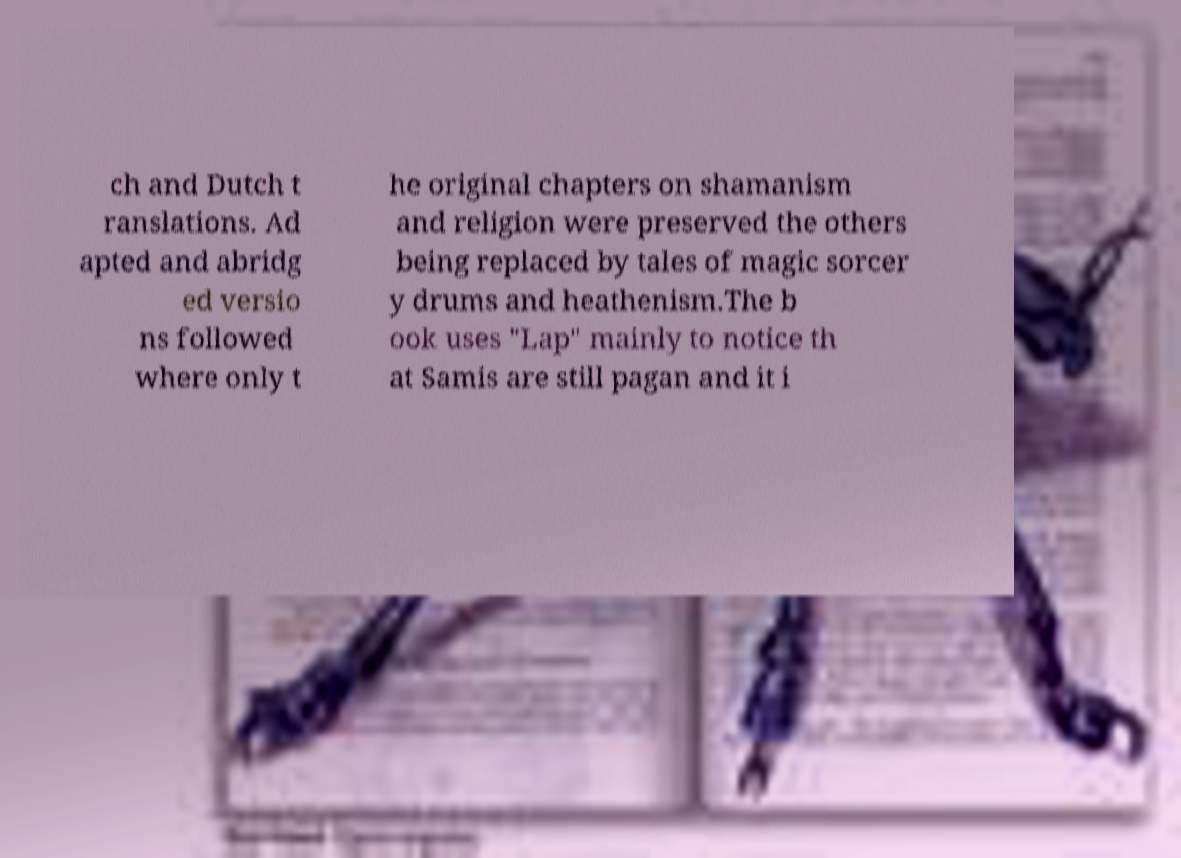For documentation purposes, I need the text within this image transcribed. Could you provide that? ch and Dutch t ranslations. Ad apted and abridg ed versio ns followed where only t he original chapters on shamanism and religion were preserved the others being replaced by tales of magic sorcer y drums and heathenism.The b ook uses "Lap" mainly to notice th at Samis are still pagan and it i 